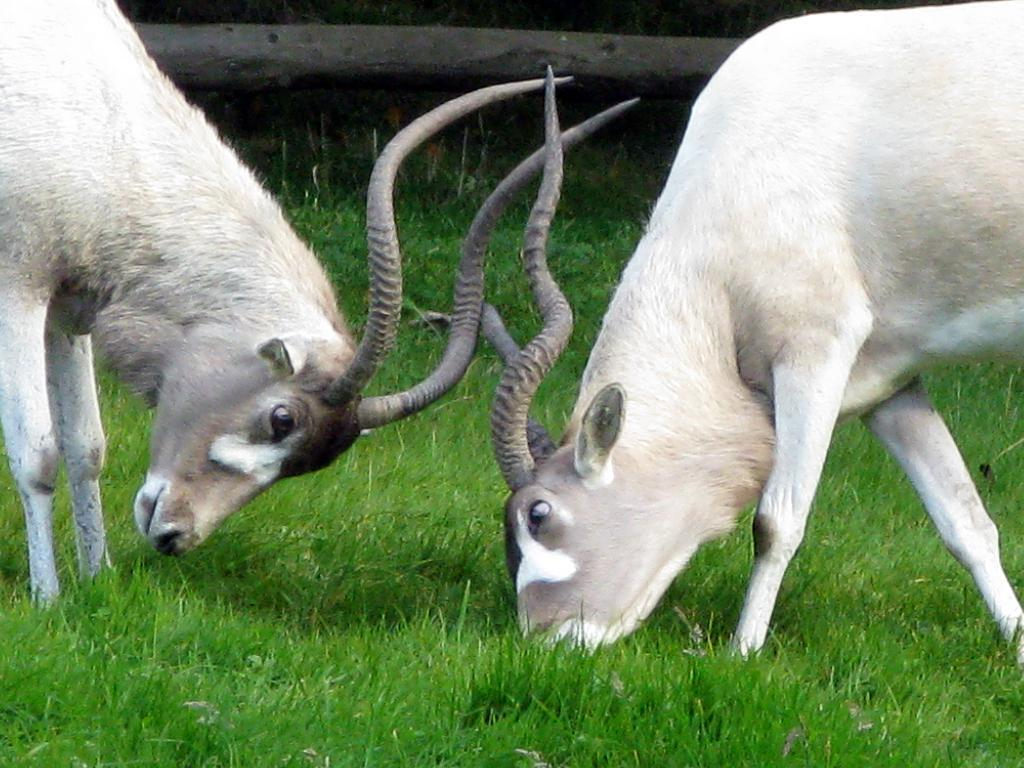How many animals are present in the image? There are two animals in the image. What are the animals doing in the image? The animals are eating grass in the image. What color is the grass that the animals are eating? The grass is green. What else can be seen in the image besides the animals and grass? There is a pole and the ground visible in the image. What type of appliance can be seen in the image? There is no appliance present in the image. How long does it take for the animals to eat the grass in the image? The image does not provide information about the duration of the animals eating the grass, so it cannot be determined from the image. 